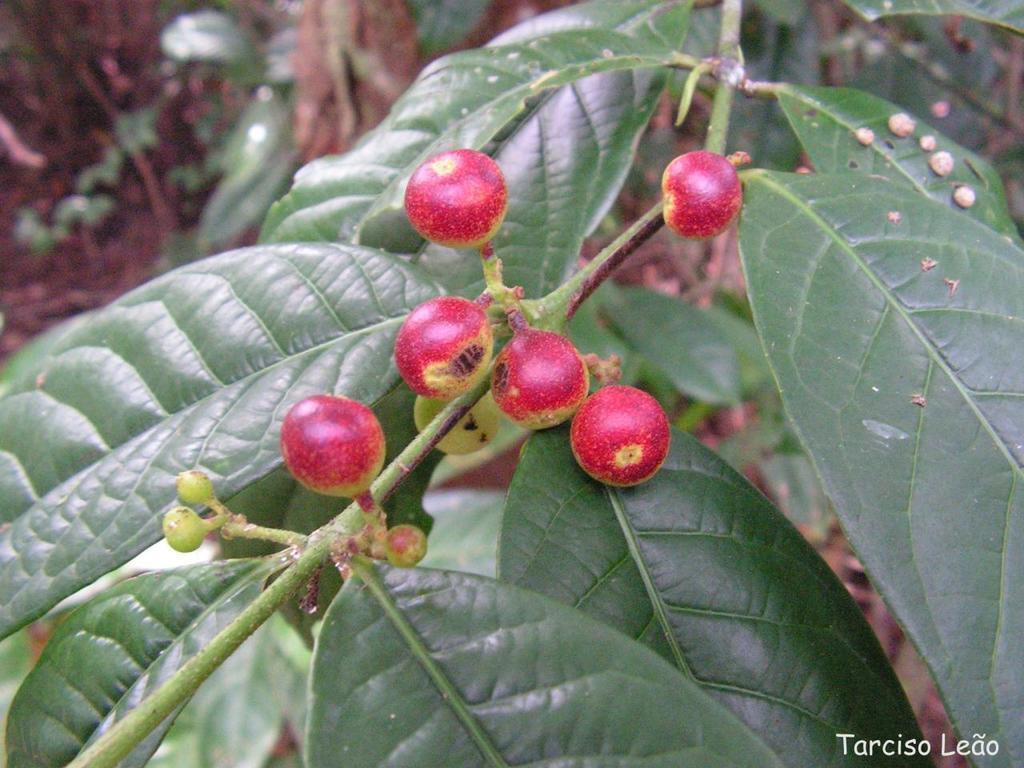Please provide a concise description of this image. Here I can see red color fruits, green color leaves and some buds to a stem. On the top of the image I can see the mud. 